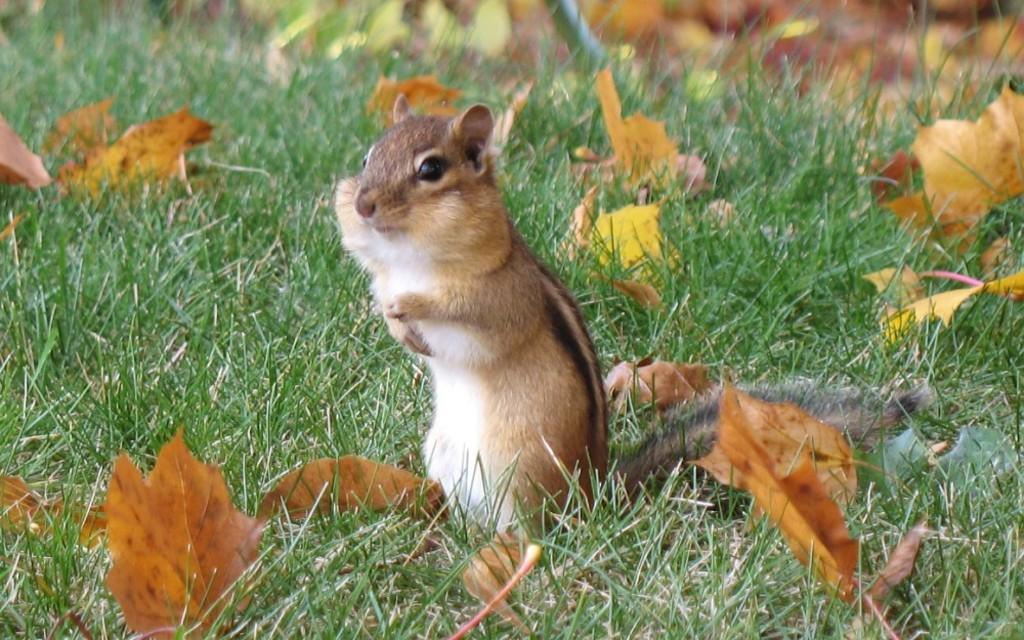What type of animal can be seen in the image? There is a squirrel in the image. What type of vegetation is visible in the image? There is grass visible in the image. What can be seen in the background of the image? Dried leaves are present in the background of the image. What type of meal is the squirrel eating in the image? The image does not show the squirrel eating a meal, so it cannot be determined from the image. 